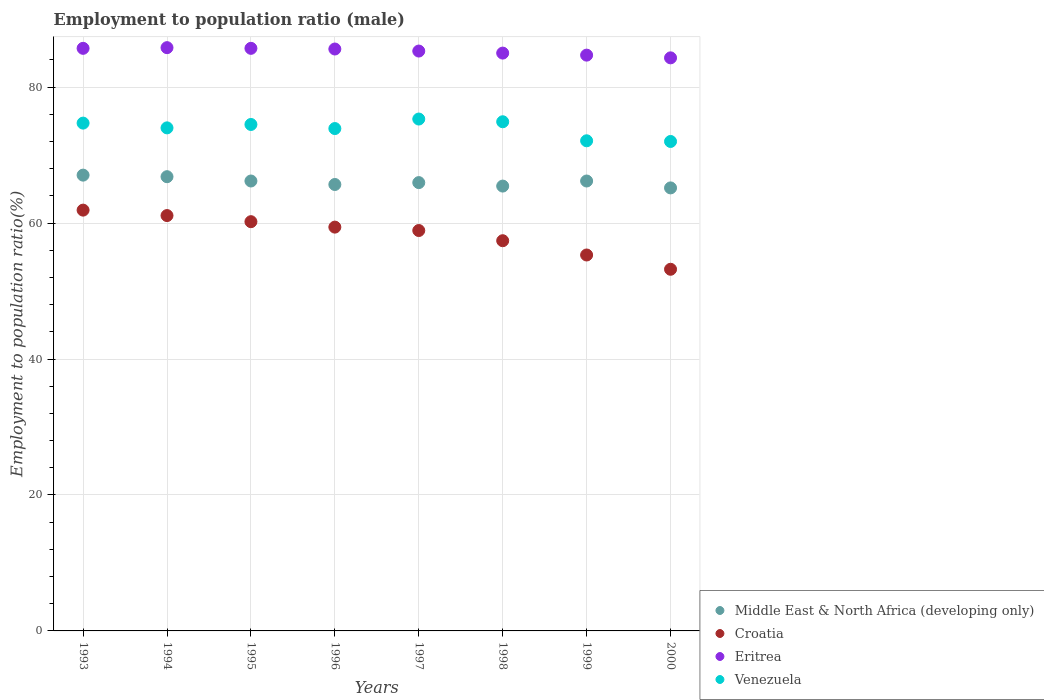What is the employment to population ratio in Croatia in 1996?
Give a very brief answer. 59.4. Across all years, what is the maximum employment to population ratio in Eritrea?
Ensure brevity in your answer.  85.8. What is the total employment to population ratio in Middle East & North Africa (developing only) in the graph?
Your answer should be very brief. 528.46. What is the difference between the employment to population ratio in Venezuela in 1994 and that in 1996?
Offer a terse response. 0.1. What is the average employment to population ratio in Eritrea per year?
Your response must be concise. 85.26. In the year 1998, what is the difference between the employment to population ratio in Croatia and employment to population ratio in Venezuela?
Offer a terse response. -17.5. In how many years, is the employment to population ratio in Venezuela greater than 4 %?
Offer a very short reply. 8. What is the ratio of the employment to population ratio in Croatia in 1996 to that in 2000?
Provide a succinct answer. 1.12. Is the employment to population ratio in Middle East & North Africa (developing only) in 1995 less than that in 1999?
Make the answer very short. No. Is the difference between the employment to population ratio in Croatia in 1995 and 1998 greater than the difference between the employment to population ratio in Venezuela in 1995 and 1998?
Make the answer very short. Yes. What is the difference between the highest and the second highest employment to population ratio in Venezuela?
Your answer should be compact. 0.4. What is the difference between the highest and the lowest employment to population ratio in Middle East & North Africa (developing only)?
Ensure brevity in your answer.  1.88. Is it the case that in every year, the sum of the employment to population ratio in Croatia and employment to population ratio in Venezuela  is greater than the employment to population ratio in Eritrea?
Provide a short and direct response. Yes. Is the employment to population ratio in Middle East & North Africa (developing only) strictly less than the employment to population ratio in Eritrea over the years?
Offer a very short reply. Yes. How many years are there in the graph?
Offer a very short reply. 8. Are the values on the major ticks of Y-axis written in scientific E-notation?
Offer a very short reply. No. Does the graph contain any zero values?
Your response must be concise. No. Does the graph contain grids?
Ensure brevity in your answer.  Yes. How many legend labels are there?
Offer a very short reply. 4. How are the legend labels stacked?
Keep it short and to the point. Vertical. What is the title of the graph?
Ensure brevity in your answer.  Employment to population ratio (male). What is the Employment to population ratio(%) in Middle East & North Africa (developing only) in 1993?
Offer a very short reply. 67.05. What is the Employment to population ratio(%) of Croatia in 1993?
Offer a terse response. 61.9. What is the Employment to population ratio(%) in Eritrea in 1993?
Your response must be concise. 85.7. What is the Employment to population ratio(%) of Venezuela in 1993?
Provide a short and direct response. 74.7. What is the Employment to population ratio(%) of Middle East & North Africa (developing only) in 1994?
Make the answer very short. 66.82. What is the Employment to population ratio(%) in Croatia in 1994?
Your answer should be very brief. 61.1. What is the Employment to population ratio(%) in Eritrea in 1994?
Ensure brevity in your answer.  85.8. What is the Employment to population ratio(%) in Venezuela in 1994?
Offer a terse response. 74. What is the Employment to population ratio(%) of Middle East & North Africa (developing only) in 1995?
Your answer should be very brief. 66.18. What is the Employment to population ratio(%) in Croatia in 1995?
Your answer should be compact. 60.2. What is the Employment to population ratio(%) of Eritrea in 1995?
Offer a terse response. 85.7. What is the Employment to population ratio(%) of Venezuela in 1995?
Offer a very short reply. 74.5. What is the Employment to population ratio(%) of Middle East & North Africa (developing only) in 1996?
Give a very brief answer. 65.67. What is the Employment to population ratio(%) of Croatia in 1996?
Provide a short and direct response. 59.4. What is the Employment to population ratio(%) of Eritrea in 1996?
Make the answer very short. 85.6. What is the Employment to population ratio(%) in Venezuela in 1996?
Provide a succinct answer. 73.9. What is the Employment to population ratio(%) of Middle East & North Africa (developing only) in 1997?
Offer a very short reply. 65.95. What is the Employment to population ratio(%) of Croatia in 1997?
Give a very brief answer. 58.9. What is the Employment to population ratio(%) in Eritrea in 1997?
Give a very brief answer. 85.3. What is the Employment to population ratio(%) in Venezuela in 1997?
Your answer should be very brief. 75.3. What is the Employment to population ratio(%) in Middle East & North Africa (developing only) in 1998?
Make the answer very short. 65.44. What is the Employment to population ratio(%) in Croatia in 1998?
Offer a terse response. 57.4. What is the Employment to population ratio(%) of Eritrea in 1998?
Your response must be concise. 85. What is the Employment to population ratio(%) in Venezuela in 1998?
Offer a terse response. 74.9. What is the Employment to population ratio(%) of Middle East & North Africa (developing only) in 1999?
Your response must be concise. 66.18. What is the Employment to population ratio(%) of Croatia in 1999?
Ensure brevity in your answer.  55.3. What is the Employment to population ratio(%) of Eritrea in 1999?
Your answer should be compact. 84.7. What is the Employment to population ratio(%) of Venezuela in 1999?
Your response must be concise. 72.1. What is the Employment to population ratio(%) of Middle East & North Africa (developing only) in 2000?
Ensure brevity in your answer.  65.17. What is the Employment to population ratio(%) of Croatia in 2000?
Give a very brief answer. 53.2. What is the Employment to population ratio(%) of Eritrea in 2000?
Offer a terse response. 84.3. What is the Employment to population ratio(%) in Venezuela in 2000?
Your answer should be compact. 72. Across all years, what is the maximum Employment to population ratio(%) in Middle East & North Africa (developing only)?
Provide a short and direct response. 67.05. Across all years, what is the maximum Employment to population ratio(%) in Croatia?
Your response must be concise. 61.9. Across all years, what is the maximum Employment to population ratio(%) of Eritrea?
Offer a terse response. 85.8. Across all years, what is the maximum Employment to population ratio(%) of Venezuela?
Offer a very short reply. 75.3. Across all years, what is the minimum Employment to population ratio(%) in Middle East & North Africa (developing only)?
Offer a very short reply. 65.17. Across all years, what is the minimum Employment to population ratio(%) in Croatia?
Make the answer very short. 53.2. Across all years, what is the minimum Employment to population ratio(%) of Eritrea?
Offer a terse response. 84.3. What is the total Employment to population ratio(%) in Middle East & North Africa (developing only) in the graph?
Give a very brief answer. 528.46. What is the total Employment to population ratio(%) of Croatia in the graph?
Keep it short and to the point. 467.4. What is the total Employment to population ratio(%) of Eritrea in the graph?
Keep it short and to the point. 682.1. What is the total Employment to population ratio(%) of Venezuela in the graph?
Keep it short and to the point. 591.4. What is the difference between the Employment to population ratio(%) of Middle East & North Africa (developing only) in 1993 and that in 1994?
Provide a short and direct response. 0.23. What is the difference between the Employment to population ratio(%) of Eritrea in 1993 and that in 1994?
Keep it short and to the point. -0.1. What is the difference between the Employment to population ratio(%) of Venezuela in 1993 and that in 1994?
Your answer should be compact. 0.7. What is the difference between the Employment to population ratio(%) of Middle East & North Africa (developing only) in 1993 and that in 1995?
Your answer should be very brief. 0.86. What is the difference between the Employment to population ratio(%) in Eritrea in 1993 and that in 1995?
Your response must be concise. 0. What is the difference between the Employment to population ratio(%) in Venezuela in 1993 and that in 1995?
Make the answer very short. 0.2. What is the difference between the Employment to population ratio(%) in Middle East & North Africa (developing only) in 1993 and that in 1996?
Your response must be concise. 1.38. What is the difference between the Employment to population ratio(%) of Croatia in 1993 and that in 1996?
Provide a short and direct response. 2.5. What is the difference between the Employment to population ratio(%) in Venezuela in 1993 and that in 1996?
Your response must be concise. 0.8. What is the difference between the Employment to population ratio(%) in Middle East & North Africa (developing only) in 1993 and that in 1997?
Give a very brief answer. 1.1. What is the difference between the Employment to population ratio(%) of Croatia in 1993 and that in 1997?
Provide a short and direct response. 3. What is the difference between the Employment to population ratio(%) in Middle East & North Africa (developing only) in 1993 and that in 1998?
Keep it short and to the point. 1.61. What is the difference between the Employment to population ratio(%) of Croatia in 1993 and that in 1998?
Your answer should be very brief. 4.5. What is the difference between the Employment to population ratio(%) of Eritrea in 1993 and that in 1998?
Your response must be concise. 0.7. What is the difference between the Employment to population ratio(%) of Middle East & North Africa (developing only) in 1993 and that in 1999?
Offer a terse response. 0.86. What is the difference between the Employment to population ratio(%) in Croatia in 1993 and that in 1999?
Offer a terse response. 6.6. What is the difference between the Employment to population ratio(%) of Eritrea in 1993 and that in 1999?
Offer a very short reply. 1. What is the difference between the Employment to population ratio(%) of Venezuela in 1993 and that in 1999?
Ensure brevity in your answer.  2.6. What is the difference between the Employment to population ratio(%) of Middle East & North Africa (developing only) in 1993 and that in 2000?
Your answer should be very brief. 1.88. What is the difference between the Employment to population ratio(%) in Venezuela in 1993 and that in 2000?
Make the answer very short. 2.7. What is the difference between the Employment to population ratio(%) in Middle East & North Africa (developing only) in 1994 and that in 1995?
Offer a terse response. 0.63. What is the difference between the Employment to population ratio(%) of Croatia in 1994 and that in 1995?
Your response must be concise. 0.9. What is the difference between the Employment to population ratio(%) in Middle East & North Africa (developing only) in 1994 and that in 1996?
Your response must be concise. 1.15. What is the difference between the Employment to population ratio(%) of Middle East & North Africa (developing only) in 1994 and that in 1997?
Your response must be concise. 0.87. What is the difference between the Employment to population ratio(%) in Eritrea in 1994 and that in 1997?
Offer a very short reply. 0.5. What is the difference between the Employment to population ratio(%) of Venezuela in 1994 and that in 1997?
Your answer should be compact. -1.3. What is the difference between the Employment to population ratio(%) in Middle East & North Africa (developing only) in 1994 and that in 1998?
Provide a succinct answer. 1.38. What is the difference between the Employment to population ratio(%) in Croatia in 1994 and that in 1998?
Your answer should be compact. 3.7. What is the difference between the Employment to population ratio(%) in Eritrea in 1994 and that in 1998?
Your answer should be very brief. 0.8. What is the difference between the Employment to population ratio(%) in Venezuela in 1994 and that in 1998?
Provide a short and direct response. -0.9. What is the difference between the Employment to population ratio(%) in Middle East & North Africa (developing only) in 1994 and that in 1999?
Provide a succinct answer. 0.63. What is the difference between the Employment to population ratio(%) in Croatia in 1994 and that in 1999?
Offer a terse response. 5.8. What is the difference between the Employment to population ratio(%) of Eritrea in 1994 and that in 1999?
Make the answer very short. 1.1. What is the difference between the Employment to population ratio(%) of Venezuela in 1994 and that in 1999?
Your answer should be compact. 1.9. What is the difference between the Employment to population ratio(%) in Middle East & North Africa (developing only) in 1994 and that in 2000?
Your answer should be very brief. 1.65. What is the difference between the Employment to population ratio(%) of Eritrea in 1994 and that in 2000?
Make the answer very short. 1.5. What is the difference between the Employment to population ratio(%) in Venezuela in 1994 and that in 2000?
Offer a terse response. 2. What is the difference between the Employment to population ratio(%) of Middle East & North Africa (developing only) in 1995 and that in 1996?
Offer a terse response. 0.51. What is the difference between the Employment to population ratio(%) of Croatia in 1995 and that in 1996?
Offer a terse response. 0.8. What is the difference between the Employment to population ratio(%) in Eritrea in 1995 and that in 1996?
Ensure brevity in your answer.  0.1. What is the difference between the Employment to population ratio(%) of Venezuela in 1995 and that in 1996?
Offer a very short reply. 0.6. What is the difference between the Employment to population ratio(%) of Middle East & North Africa (developing only) in 1995 and that in 1997?
Give a very brief answer. 0.24. What is the difference between the Employment to population ratio(%) of Croatia in 1995 and that in 1997?
Your answer should be very brief. 1.3. What is the difference between the Employment to population ratio(%) of Eritrea in 1995 and that in 1997?
Make the answer very short. 0.4. What is the difference between the Employment to population ratio(%) in Venezuela in 1995 and that in 1997?
Your answer should be very brief. -0.8. What is the difference between the Employment to population ratio(%) of Middle East & North Africa (developing only) in 1995 and that in 1998?
Provide a succinct answer. 0.75. What is the difference between the Employment to population ratio(%) in Eritrea in 1995 and that in 1998?
Make the answer very short. 0.7. What is the difference between the Employment to population ratio(%) in Eritrea in 1995 and that in 1999?
Give a very brief answer. 1. What is the difference between the Employment to population ratio(%) in Middle East & North Africa (developing only) in 1995 and that in 2000?
Make the answer very short. 1.02. What is the difference between the Employment to population ratio(%) in Croatia in 1995 and that in 2000?
Your answer should be compact. 7. What is the difference between the Employment to population ratio(%) of Eritrea in 1995 and that in 2000?
Offer a very short reply. 1.4. What is the difference between the Employment to population ratio(%) in Venezuela in 1995 and that in 2000?
Give a very brief answer. 2.5. What is the difference between the Employment to population ratio(%) in Middle East & North Africa (developing only) in 1996 and that in 1997?
Keep it short and to the point. -0.28. What is the difference between the Employment to population ratio(%) in Venezuela in 1996 and that in 1997?
Offer a terse response. -1.4. What is the difference between the Employment to population ratio(%) of Middle East & North Africa (developing only) in 1996 and that in 1998?
Give a very brief answer. 0.23. What is the difference between the Employment to population ratio(%) of Eritrea in 1996 and that in 1998?
Your answer should be very brief. 0.6. What is the difference between the Employment to population ratio(%) of Venezuela in 1996 and that in 1998?
Provide a succinct answer. -1. What is the difference between the Employment to population ratio(%) in Middle East & North Africa (developing only) in 1996 and that in 1999?
Your response must be concise. -0.51. What is the difference between the Employment to population ratio(%) of Middle East & North Africa (developing only) in 1996 and that in 2000?
Offer a very short reply. 0.5. What is the difference between the Employment to population ratio(%) of Croatia in 1996 and that in 2000?
Your answer should be very brief. 6.2. What is the difference between the Employment to population ratio(%) in Venezuela in 1996 and that in 2000?
Make the answer very short. 1.9. What is the difference between the Employment to population ratio(%) of Middle East & North Africa (developing only) in 1997 and that in 1998?
Offer a very short reply. 0.51. What is the difference between the Employment to population ratio(%) of Eritrea in 1997 and that in 1998?
Offer a terse response. 0.3. What is the difference between the Employment to population ratio(%) of Venezuela in 1997 and that in 1998?
Offer a terse response. 0.4. What is the difference between the Employment to population ratio(%) in Middle East & North Africa (developing only) in 1997 and that in 1999?
Keep it short and to the point. -0.24. What is the difference between the Employment to population ratio(%) in Middle East & North Africa (developing only) in 1997 and that in 2000?
Provide a short and direct response. 0.78. What is the difference between the Employment to population ratio(%) in Croatia in 1997 and that in 2000?
Give a very brief answer. 5.7. What is the difference between the Employment to population ratio(%) of Middle East & North Africa (developing only) in 1998 and that in 1999?
Your response must be concise. -0.75. What is the difference between the Employment to population ratio(%) of Croatia in 1998 and that in 1999?
Offer a terse response. 2.1. What is the difference between the Employment to population ratio(%) in Middle East & North Africa (developing only) in 1998 and that in 2000?
Keep it short and to the point. 0.27. What is the difference between the Employment to population ratio(%) of Venezuela in 1998 and that in 2000?
Offer a very short reply. 2.9. What is the difference between the Employment to population ratio(%) of Middle East & North Africa (developing only) in 1999 and that in 2000?
Give a very brief answer. 1.02. What is the difference between the Employment to population ratio(%) in Middle East & North Africa (developing only) in 1993 and the Employment to population ratio(%) in Croatia in 1994?
Ensure brevity in your answer.  5.95. What is the difference between the Employment to population ratio(%) in Middle East & North Africa (developing only) in 1993 and the Employment to population ratio(%) in Eritrea in 1994?
Your answer should be very brief. -18.75. What is the difference between the Employment to population ratio(%) in Middle East & North Africa (developing only) in 1993 and the Employment to population ratio(%) in Venezuela in 1994?
Your response must be concise. -6.95. What is the difference between the Employment to population ratio(%) in Croatia in 1993 and the Employment to population ratio(%) in Eritrea in 1994?
Offer a very short reply. -23.9. What is the difference between the Employment to population ratio(%) of Croatia in 1993 and the Employment to population ratio(%) of Venezuela in 1994?
Provide a short and direct response. -12.1. What is the difference between the Employment to population ratio(%) of Middle East & North Africa (developing only) in 1993 and the Employment to population ratio(%) of Croatia in 1995?
Your answer should be compact. 6.85. What is the difference between the Employment to population ratio(%) in Middle East & North Africa (developing only) in 1993 and the Employment to population ratio(%) in Eritrea in 1995?
Give a very brief answer. -18.65. What is the difference between the Employment to population ratio(%) of Middle East & North Africa (developing only) in 1993 and the Employment to population ratio(%) of Venezuela in 1995?
Offer a terse response. -7.45. What is the difference between the Employment to population ratio(%) of Croatia in 1993 and the Employment to population ratio(%) of Eritrea in 1995?
Your answer should be compact. -23.8. What is the difference between the Employment to population ratio(%) of Eritrea in 1993 and the Employment to population ratio(%) of Venezuela in 1995?
Provide a succinct answer. 11.2. What is the difference between the Employment to population ratio(%) of Middle East & North Africa (developing only) in 1993 and the Employment to population ratio(%) of Croatia in 1996?
Your answer should be compact. 7.65. What is the difference between the Employment to population ratio(%) of Middle East & North Africa (developing only) in 1993 and the Employment to population ratio(%) of Eritrea in 1996?
Your answer should be very brief. -18.55. What is the difference between the Employment to population ratio(%) in Middle East & North Africa (developing only) in 1993 and the Employment to population ratio(%) in Venezuela in 1996?
Your answer should be compact. -6.85. What is the difference between the Employment to population ratio(%) in Croatia in 1993 and the Employment to population ratio(%) in Eritrea in 1996?
Provide a short and direct response. -23.7. What is the difference between the Employment to population ratio(%) in Middle East & North Africa (developing only) in 1993 and the Employment to population ratio(%) in Croatia in 1997?
Offer a very short reply. 8.15. What is the difference between the Employment to population ratio(%) of Middle East & North Africa (developing only) in 1993 and the Employment to population ratio(%) of Eritrea in 1997?
Your answer should be very brief. -18.25. What is the difference between the Employment to population ratio(%) of Middle East & North Africa (developing only) in 1993 and the Employment to population ratio(%) of Venezuela in 1997?
Your response must be concise. -8.25. What is the difference between the Employment to population ratio(%) in Croatia in 1993 and the Employment to population ratio(%) in Eritrea in 1997?
Your answer should be very brief. -23.4. What is the difference between the Employment to population ratio(%) of Eritrea in 1993 and the Employment to population ratio(%) of Venezuela in 1997?
Your answer should be compact. 10.4. What is the difference between the Employment to population ratio(%) of Middle East & North Africa (developing only) in 1993 and the Employment to population ratio(%) of Croatia in 1998?
Your answer should be compact. 9.65. What is the difference between the Employment to population ratio(%) of Middle East & North Africa (developing only) in 1993 and the Employment to population ratio(%) of Eritrea in 1998?
Your response must be concise. -17.95. What is the difference between the Employment to population ratio(%) of Middle East & North Africa (developing only) in 1993 and the Employment to population ratio(%) of Venezuela in 1998?
Keep it short and to the point. -7.85. What is the difference between the Employment to population ratio(%) of Croatia in 1993 and the Employment to population ratio(%) of Eritrea in 1998?
Make the answer very short. -23.1. What is the difference between the Employment to population ratio(%) of Middle East & North Africa (developing only) in 1993 and the Employment to population ratio(%) of Croatia in 1999?
Offer a very short reply. 11.75. What is the difference between the Employment to population ratio(%) in Middle East & North Africa (developing only) in 1993 and the Employment to population ratio(%) in Eritrea in 1999?
Your response must be concise. -17.65. What is the difference between the Employment to population ratio(%) of Middle East & North Africa (developing only) in 1993 and the Employment to population ratio(%) of Venezuela in 1999?
Provide a succinct answer. -5.05. What is the difference between the Employment to population ratio(%) of Croatia in 1993 and the Employment to population ratio(%) of Eritrea in 1999?
Ensure brevity in your answer.  -22.8. What is the difference between the Employment to population ratio(%) in Croatia in 1993 and the Employment to population ratio(%) in Venezuela in 1999?
Provide a short and direct response. -10.2. What is the difference between the Employment to population ratio(%) in Middle East & North Africa (developing only) in 1993 and the Employment to population ratio(%) in Croatia in 2000?
Offer a very short reply. 13.85. What is the difference between the Employment to population ratio(%) in Middle East & North Africa (developing only) in 1993 and the Employment to population ratio(%) in Eritrea in 2000?
Make the answer very short. -17.25. What is the difference between the Employment to population ratio(%) in Middle East & North Africa (developing only) in 1993 and the Employment to population ratio(%) in Venezuela in 2000?
Make the answer very short. -4.95. What is the difference between the Employment to population ratio(%) in Croatia in 1993 and the Employment to population ratio(%) in Eritrea in 2000?
Offer a terse response. -22.4. What is the difference between the Employment to population ratio(%) of Eritrea in 1993 and the Employment to population ratio(%) of Venezuela in 2000?
Ensure brevity in your answer.  13.7. What is the difference between the Employment to population ratio(%) of Middle East & North Africa (developing only) in 1994 and the Employment to population ratio(%) of Croatia in 1995?
Make the answer very short. 6.62. What is the difference between the Employment to population ratio(%) of Middle East & North Africa (developing only) in 1994 and the Employment to population ratio(%) of Eritrea in 1995?
Your response must be concise. -18.88. What is the difference between the Employment to population ratio(%) in Middle East & North Africa (developing only) in 1994 and the Employment to population ratio(%) in Venezuela in 1995?
Your answer should be compact. -7.68. What is the difference between the Employment to population ratio(%) in Croatia in 1994 and the Employment to population ratio(%) in Eritrea in 1995?
Provide a short and direct response. -24.6. What is the difference between the Employment to population ratio(%) in Croatia in 1994 and the Employment to population ratio(%) in Venezuela in 1995?
Ensure brevity in your answer.  -13.4. What is the difference between the Employment to population ratio(%) in Middle East & North Africa (developing only) in 1994 and the Employment to population ratio(%) in Croatia in 1996?
Your response must be concise. 7.42. What is the difference between the Employment to population ratio(%) in Middle East & North Africa (developing only) in 1994 and the Employment to population ratio(%) in Eritrea in 1996?
Your response must be concise. -18.78. What is the difference between the Employment to population ratio(%) in Middle East & North Africa (developing only) in 1994 and the Employment to population ratio(%) in Venezuela in 1996?
Provide a short and direct response. -7.08. What is the difference between the Employment to population ratio(%) in Croatia in 1994 and the Employment to population ratio(%) in Eritrea in 1996?
Provide a short and direct response. -24.5. What is the difference between the Employment to population ratio(%) in Croatia in 1994 and the Employment to population ratio(%) in Venezuela in 1996?
Your answer should be compact. -12.8. What is the difference between the Employment to population ratio(%) of Middle East & North Africa (developing only) in 1994 and the Employment to population ratio(%) of Croatia in 1997?
Keep it short and to the point. 7.92. What is the difference between the Employment to population ratio(%) in Middle East & North Africa (developing only) in 1994 and the Employment to population ratio(%) in Eritrea in 1997?
Make the answer very short. -18.48. What is the difference between the Employment to population ratio(%) of Middle East & North Africa (developing only) in 1994 and the Employment to population ratio(%) of Venezuela in 1997?
Provide a succinct answer. -8.48. What is the difference between the Employment to population ratio(%) of Croatia in 1994 and the Employment to population ratio(%) of Eritrea in 1997?
Provide a succinct answer. -24.2. What is the difference between the Employment to population ratio(%) in Croatia in 1994 and the Employment to population ratio(%) in Venezuela in 1997?
Give a very brief answer. -14.2. What is the difference between the Employment to population ratio(%) of Eritrea in 1994 and the Employment to population ratio(%) of Venezuela in 1997?
Your response must be concise. 10.5. What is the difference between the Employment to population ratio(%) of Middle East & North Africa (developing only) in 1994 and the Employment to population ratio(%) of Croatia in 1998?
Your answer should be very brief. 9.42. What is the difference between the Employment to population ratio(%) of Middle East & North Africa (developing only) in 1994 and the Employment to population ratio(%) of Eritrea in 1998?
Your response must be concise. -18.18. What is the difference between the Employment to population ratio(%) of Middle East & North Africa (developing only) in 1994 and the Employment to population ratio(%) of Venezuela in 1998?
Make the answer very short. -8.08. What is the difference between the Employment to population ratio(%) in Croatia in 1994 and the Employment to population ratio(%) in Eritrea in 1998?
Your answer should be very brief. -23.9. What is the difference between the Employment to population ratio(%) of Middle East & North Africa (developing only) in 1994 and the Employment to population ratio(%) of Croatia in 1999?
Provide a succinct answer. 11.52. What is the difference between the Employment to population ratio(%) of Middle East & North Africa (developing only) in 1994 and the Employment to population ratio(%) of Eritrea in 1999?
Keep it short and to the point. -17.88. What is the difference between the Employment to population ratio(%) in Middle East & North Africa (developing only) in 1994 and the Employment to population ratio(%) in Venezuela in 1999?
Make the answer very short. -5.28. What is the difference between the Employment to population ratio(%) in Croatia in 1994 and the Employment to population ratio(%) in Eritrea in 1999?
Offer a terse response. -23.6. What is the difference between the Employment to population ratio(%) in Middle East & North Africa (developing only) in 1994 and the Employment to population ratio(%) in Croatia in 2000?
Offer a very short reply. 13.62. What is the difference between the Employment to population ratio(%) in Middle East & North Africa (developing only) in 1994 and the Employment to population ratio(%) in Eritrea in 2000?
Your answer should be very brief. -17.48. What is the difference between the Employment to population ratio(%) of Middle East & North Africa (developing only) in 1994 and the Employment to population ratio(%) of Venezuela in 2000?
Offer a very short reply. -5.18. What is the difference between the Employment to population ratio(%) of Croatia in 1994 and the Employment to population ratio(%) of Eritrea in 2000?
Keep it short and to the point. -23.2. What is the difference between the Employment to population ratio(%) in Croatia in 1994 and the Employment to population ratio(%) in Venezuela in 2000?
Your answer should be very brief. -10.9. What is the difference between the Employment to population ratio(%) in Eritrea in 1994 and the Employment to population ratio(%) in Venezuela in 2000?
Your answer should be compact. 13.8. What is the difference between the Employment to population ratio(%) of Middle East & North Africa (developing only) in 1995 and the Employment to population ratio(%) of Croatia in 1996?
Make the answer very short. 6.78. What is the difference between the Employment to population ratio(%) in Middle East & North Africa (developing only) in 1995 and the Employment to population ratio(%) in Eritrea in 1996?
Provide a short and direct response. -19.42. What is the difference between the Employment to population ratio(%) in Middle East & North Africa (developing only) in 1995 and the Employment to population ratio(%) in Venezuela in 1996?
Your answer should be compact. -7.72. What is the difference between the Employment to population ratio(%) of Croatia in 1995 and the Employment to population ratio(%) of Eritrea in 1996?
Give a very brief answer. -25.4. What is the difference between the Employment to population ratio(%) of Croatia in 1995 and the Employment to population ratio(%) of Venezuela in 1996?
Make the answer very short. -13.7. What is the difference between the Employment to population ratio(%) in Eritrea in 1995 and the Employment to population ratio(%) in Venezuela in 1996?
Ensure brevity in your answer.  11.8. What is the difference between the Employment to population ratio(%) of Middle East & North Africa (developing only) in 1995 and the Employment to population ratio(%) of Croatia in 1997?
Provide a short and direct response. 7.28. What is the difference between the Employment to population ratio(%) of Middle East & North Africa (developing only) in 1995 and the Employment to population ratio(%) of Eritrea in 1997?
Provide a succinct answer. -19.12. What is the difference between the Employment to population ratio(%) in Middle East & North Africa (developing only) in 1995 and the Employment to population ratio(%) in Venezuela in 1997?
Offer a terse response. -9.12. What is the difference between the Employment to population ratio(%) in Croatia in 1995 and the Employment to population ratio(%) in Eritrea in 1997?
Your answer should be compact. -25.1. What is the difference between the Employment to population ratio(%) in Croatia in 1995 and the Employment to population ratio(%) in Venezuela in 1997?
Make the answer very short. -15.1. What is the difference between the Employment to population ratio(%) of Eritrea in 1995 and the Employment to population ratio(%) of Venezuela in 1997?
Your response must be concise. 10.4. What is the difference between the Employment to population ratio(%) in Middle East & North Africa (developing only) in 1995 and the Employment to population ratio(%) in Croatia in 1998?
Ensure brevity in your answer.  8.78. What is the difference between the Employment to population ratio(%) of Middle East & North Africa (developing only) in 1995 and the Employment to population ratio(%) of Eritrea in 1998?
Give a very brief answer. -18.82. What is the difference between the Employment to population ratio(%) in Middle East & North Africa (developing only) in 1995 and the Employment to population ratio(%) in Venezuela in 1998?
Give a very brief answer. -8.72. What is the difference between the Employment to population ratio(%) in Croatia in 1995 and the Employment to population ratio(%) in Eritrea in 1998?
Offer a terse response. -24.8. What is the difference between the Employment to population ratio(%) in Croatia in 1995 and the Employment to population ratio(%) in Venezuela in 1998?
Provide a succinct answer. -14.7. What is the difference between the Employment to population ratio(%) in Middle East & North Africa (developing only) in 1995 and the Employment to population ratio(%) in Croatia in 1999?
Provide a succinct answer. 10.88. What is the difference between the Employment to population ratio(%) of Middle East & North Africa (developing only) in 1995 and the Employment to population ratio(%) of Eritrea in 1999?
Offer a terse response. -18.52. What is the difference between the Employment to population ratio(%) in Middle East & North Africa (developing only) in 1995 and the Employment to population ratio(%) in Venezuela in 1999?
Your answer should be very brief. -5.92. What is the difference between the Employment to population ratio(%) in Croatia in 1995 and the Employment to population ratio(%) in Eritrea in 1999?
Keep it short and to the point. -24.5. What is the difference between the Employment to population ratio(%) in Eritrea in 1995 and the Employment to population ratio(%) in Venezuela in 1999?
Your answer should be very brief. 13.6. What is the difference between the Employment to population ratio(%) of Middle East & North Africa (developing only) in 1995 and the Employment to population ratio(%) of Croatia in 2000?
Ensure brevity in your answer.  12.98. What is the difference between the Employment to population ratio(%) in Middle East & North Africa (developing only) in 1995 and the Employment to population ratio(%) in Eritrea in 2000?
Your response must be concise. -18.12. What is the difference between the Employment to population ratio(%) of Middle East & North Africa (developing only) in 1995 and the Employment to population ratio(%) of Venezuela in 2000?
Your response must be concise. -5.82. What is the difference between the Employment to population ratio(%) in Croatia in 1995 and the Employment to population ratio(%) in Eritrea in 2000?
Your response must be concise. -24.1. What is the difference between the Employment to population ratio(%) of Eritrea in 1995 and the Employment to population ratio(%) of Venezuela in 2000?
Provide a succinct answer. 13.7. What is the difference between the Employment to population ratio(%) in Middle East & North Africa (developing only) in 1996 and the Employment to population ratio(%) in Croatia in 1997?
Keep it short and to the point. 6.77. What is the difference between the Employment to population ratio(%) of Middle East & North Africa (developing only) in 1996 and the Employment to population ratio(%) of Eritrea in 1997?
Your response must be concise. -19.63. What is the difference between the Employment to population ratio(%) in Middle East & North Africa (developing only) in 1996 and the Employment to population ratio(%) in Venezuela in 1997?
Offer a very short reply. -9.63. What is the difference between the Employment to population ratio(%) in Croatia in 1996 and the Employment to population ratio(%) in Eritrea in 1997?
Offer a very short reply. -25.9. What is the difference between the Employment to population ratio(%) of Croatia in 1996 and the Employment to population ratio(%) of Venezuela in 1997?
Your response must be concise. -15.9. What is the difference between the Employment to population ratio(%) of Eritrea in 1996 and the Employment to population ratio(%) of Venezuela in 1997?
Offer a very short reply. 10.3. What is the difference between the Employment to population ratio(%) of Middle East & North Africa (developing only) in 1996 and the Employment to population ratio(%) of Croatia in 1998?
Offer a very short reply. 8.27. What is the difference between the Employment to population ratio(%) of Middle East & North Africa (developing only) in 1996 and the Employment to population ratio(%) of Eritrea in 1998?
Your answer should be compact. -19.33. What is the difference between the Employment to population ratio(%) of Middle East & North Africa (developing only) in 1996 and the Employment to population ratio(%) of Venezuela in 1998?
Give a very brief answer. -9.23. What is the difference between the Employment to population ratio(%) of Croatia in 1996 and the Employment to population ratio(%) of Eritrea in 1998?
Keep it short and to the point. -25.6. What is the difference between the Employment to population ratio(%) in Croatia in 1996 and the Employment to population ratio(%) in Venezuela in 1998?
Your answer should be compact. -15.5. What is the difference between the Employment to population ratio(%) of Middle East & North Africa (developing only) in 1996 and the Employment to population ratio(%) of Croatia in 1999?
Provide a short and direct response. 10.37. What is the difference between the Employment to population ratio(%) of Middle East & North Africa (developing only) in 1996 and the Employment to population ratio(%) of Eritrea in 1999?
Give a very brief answer. -19.03. What is the difference between the Employment to population ratio(%) of Middle East & North Africa (developing only) in 1996 and the Employment to population ratio(%) of Venezuela in 1999?
Make the answer very short. -6.43. What is the difference between the Employment to population ratio(%) in Croatia in 1996 and the Employment to population ratio(%) in Eritrea in 1999?
Provide a succinct answer. -25.3. What is the difference between the Employment to population ratio(%) in Eritrea in 1996 and the Employment to population ratio(%) in Venezuela in 1999?
Provide a short and direct response. 13.5. What is the difference between the Employment to population ratio(%) in Middle East & North Africa (developing only) in 1996 and the Employment to population ratio(%) in Croatia in 2000?
Offer a terse response. 12.47. What is the difference between the Employment to population ratio(%) in Middle East & North Africa (developing only) in 1996 and the Employment to population ratio(%) in Eritrea in 2000?
Your answer should be very brief. -18.63. What is the difference between the Employment to population ratio(%) in Middle East & North Africa (developing only) in 1996 and the Employment to population ratio(%) in Venezuela in 2000?
Offer a terse response. -6.33. What is the difference between the Employment to population ratio(%) of Croatia in 1996 and the Employment to population ratio(%) of Eritrea in 2000?
Make the answer very short. -24.9. What is the difference between the Employment to population ratio(%) of Eritrea in 1996 and the Employment to population ratio(%) of Venezuela in 2000?
Your response must be concise. 13.6. What is the difference between the Employment to population ratio(%) of Middle East & North Africa (developing only) in 1997 and the Employment to population ratio(%) of Croatia in 1998?
Offer a very short reply. 8.55. What is the difference between the Employment to population ratio(%) of Middle East & North Africa (developing only) in 1997 and the Employment to population ratio(%) of Eritrea in 1998?
Your answer should be compact. -19.05. What is the difference between the Employment to population ratio(%) in Middle East & North Africa (developing only) in 1997 and the Employment to population ratio(%) in Venezuela in 1998?
Offer a terse response. -8.95. What is the difference between the Employment to population ratio(%) in Croatia in 1997 and the Employment to population ratio(%) in Eritrea in 1998?
Your answer should be compact. -26.1. What is the difference between the Employment to population ratio(%) of Eritrea in 1997 and the Employment to population ratio(%) of Venezuela in 1998?
Provide a succinct answer. 10.4. What is the difference between the Employment to population ratio(%) of Middle East & North Africa (developing only) in 1997 and the Employment to population ratio(%) of Croatia in 1999?
Your answer should be very brief. 10.65. What is the difference between the Employment to population ratio(%) in Middle East & North Africa (developing only) in 1997 and the Employment to population ratio(%) in Eritrea in 1999?
Keep it short and to the point. -18.75. What is the difference between the Employment to population ratio(%) in Middle East & North Africa (developing only) in 1997 and the Employment to population ratio(%) in Venezuela in 1999?
Your answer should be compact. -6.15. What is the difference between the Employment to population ratio(%) in Croatia in 1997 and the Employment to population ratio(%) in Eritrea in 1999?
Make the answer very short. -25.8. What is the difference between the Employment to population ratio(%) in Eritrea in 1997 and the Employment to population ratio(%) in Venezuela in 1999?
Provide a short and direct response. 13.2. What is the difference between the Employment to population ratio(%) in Middle East & North Africa (developing only) in 1997 and the Employment to population ratio(%) in Croatia in 2000?
Provide a short and direct response. 12.75. What is the difference between the Employment to population ratio(%) of Middle East & North Africa (developing only) in 1997 and the Employment to population ratio(%) of Eritrea in 2000?
Your answer should be compact. -18.35. What is the difference between the Employment to population ratio(%) in Middle East & North Africa (developing only) in 1997 and the Employment to population ratio(%) in Venezuela in 2000?
Give a very brief answer. -6.05. What is the difference between the Employment to population ratio(%) in Croatia in 1997 and the Employment to population ratio(%) in Eritrea in 2000?
Provide a succinct answer. -25.4. What is the difference between the Employment to population ratio(%) of Croatia in 1997 and the Employment to population ratio(%) of Venezuela in 2000?
Ensure brevity in your answer.  -13.1. What is the difference between the Employment to population ratio(%) of Middle East & North Africa (developing only) in 1998 and the Employment to population ratio(%) of Croatia in 1999?
Give a very brief answer. 10.14. What is the difference between the Employment to population ratio(%) of Middle East & North Africa (developing only) in 1998 and the Employment to population ratio(%) of Eritrea in 1999?
Offer a very short reply. -19.26. What is the difference between the Employment to population ratio(%) in Middle East & North Africa (developing only) in 1998 and the Employment to population ratio(%) in Venezuela in 1999?
Make the answer very short. -6.66. What is the difference between the Employment to population ratio(%) in Croatia in 1998 and the Employment to population ratio(%) in Eritrea in 1999?
Ensure brevity in your answer.  -27.3. What is the difference between the Employment to population ratio(%) of Croatia in 1998 and the Employment to population ratio(%) of Venezuela in 1999?
Your response must be concise. -14.7. What is the difference between the Employment to population ratio(%) in Eritrea in 1998 and the Employment to population ratio(%) in Venezuela in 1999?
Your response must be concise. 12.9. What is the difference between the Employment to population ratio(%) of Middle East & North Africa (developing only) in 1998 and the Employment to population ratio(%) of Croatia in 2000?
Make the answer very short. 12.24. What is the difference between the Employment to population ratio(%) of Middle East & North Africa (developing only) in 1998 and the Employment to population ratio(%) of Eritrea in 2000?
Give a very brief answer. -18.86. What is the difference between the Employment to population ratio(%) in Middle East & North Africa (developing only) in 1998 and the Employment to population ratio(%) in Venezuela in 2000?
Offer a terse response. -6.56. What is the difference between the Employment to population ratio(%) of Croatia in 1998 and the Employment to population ratio(%) of Eritrea in 2000?
Ensure brevity in your answer.  -26.9. What is the difference between the Employment to population ratio(%) of Croatia in 1998 and the Employment to population ratio(%) of Venezuela in 2000?
Offer a terse response. -14.6. What is the difference between the Employment to population ratio(%) in Middle East & North Africa (developing only) in 1999 and the Employment to population ratio(%) in Croatia in 2000?
Your response must be concise. 12.98. What is the difference between the Employment to population ratio(%) of Middle East & North Africa (developing only) in 1999 and the Employment to population ratio(%) of Eritrea in 2000?
Provide a succinct answer. -18.12. What is the difference between the Employment to population ratio(%) in Middle East & North Africa (developing only) in 1999 and the Employment to population ratio(%) in Venezuela in 2000?
Provide a succinct answer. -5.82. What is the difference between the Employment to population ratio(%) of Croatia in 1999 and the Employment to population ratio(%) of Eritrea in 2000?
Your answer should be compact. -29. What is the difference between the Employment to population ratio(%) in Croatia in 1999 and the Employment to population ratio(%) in Venezuela in 2000?
Give a very brief answer. -16.7. What is the average Employment to population ratio(%) in Middle East & North Africa (developing only) per year?
Your response must be concise. 66.06. What is the average Employment to population ratio(%) in Croatia per year?
Give a very brief answer. 58.42. What is the average Employment to population ratio(%) of Eritrea per year?
Make the answer very short. 85.26. What is the average Employment to population ratio(%) of Venezuela per year?
Your answer should be compact. 73.92. In the year 1993, what is the difference between the Employment to population ratio(%) of Middle East & North Africa (developing only) and Employment to population ratio(%) of Croatia?
Your answer should be compact. 5.15. In the year 1993, what is the difference between the Employment to population ratio(%) of Middle East & North Africa (developing only) and Employment to population ratio(%) of Eritrea?
Your answer should be very brief. -18.65. In the year 1993, what is the difference between the Employment to population ratio(%) of Middle East & North Africa (developing only) and Employment to population ratio(%) of Venezuela?
Keep it short and to the point. -7.65. In the year 1993, what is the difference between the Employment to population ratio(%) of Croatia and Employment to population ratio(%) of Eritrea?
Offer a terse response. -23.8. In the year 1993, what is the difference between the Employment to population ratio(%) in Eritrea and Employment to population ratio(%) in Venezuela?
Make the answer very short. 11. In the year 1994, what is the difference between the Employment to population ratio(%) in Middle East & North Africa (developing only) and Employment to population ratio(%) in Croatia?
Your answer should be very brief. 5.72. In the year 1994, what is the difference between the Employment to population ratio(%) of Middle East & North Africa (developing only) and Employment to population ratio(%) of Eritrea?
Keep it short and to the point. -18.98. In the year 1994, what is the difference between the Employment to population ratio(%) of Middle East & North Africa (developing only) and Employment to population ratio(%) of Venezuela?
Provide a short and direct response. -7.18. In the year 1994, what is the difference between the Employment to population ratio(%) of Croatia and Employment to population ratio(%) of Eritrea?
Your response must be concise. -24.7. In the year 1994, what is the difference between the Employment to population ratio(%) of Croatia and Employment to population ratio(%) of Venezuela?
Ensure brevity in your answer.  -12.9. In the year 1995, what is the difference between the Employment to population ratio(%) in Middle East & North Africa (developing only) and Employment to population ratio(%) in Croatia?
Offer a very short reply. 5.98. In the year 1995, what is the difference between the Employment to population ratio(%) of Middle East & North Africa (developing only) and Employment to population ratio(%) of Eritrea?
Offer a very short reply. -19.52. In the year 1995, what is the difference between the Employment to population ratio(%) in Middle East & North Africa (developing only) and Employment to population ratio(%) in Venezuela?
Keep it short and to the point. -8.32. In the year 1995, what is the difference between the Employment to population ratio(%) of Croatia and Employment to population ratio(%) of Eritrea?
Provide a short and direct response. -25.5. In the year 1995, what is the difference between the Employment to population ratio(%) of Croatia and Employment to population ratio(%) of Venezuela?
Your answer should be very brief. -14.3. In the year 1996, what is the difference between the Employment to population ratio(%) of Middle East & North Africa (developing only) and Employment to population ratio(%) of Croatia?
Offer a very short reply. 6.27. In the year 1996, what is the difference between the Employment to population ratio(%) of Middle East & North Africa (developing only) and Employment to population ratio(%) of Eritrea?
Provide a short and direct response. -19.93. In the year 1996, what is the difference between the Employment to population ratio(%) in Middle East & North Africa (developing only) and Employment to population ratio(%) in Venezuela?
Give a very brief answer. -8.23. In the year 1996, what is the difference between the Employment to population ratio(%) in Croatia and Employment to population ratio(%) in Eritrea?
Offer a very short reply. -26.2. In the year 1997, what is the difference between the Employment to population ratio(%) of Middle East & North Africa (developing only) and Employment to population ratio(%) of Croatia?
Provide a short and direct response. 7.05. In the year 1997, what is the difference between the Employment to population ratio(%) of Middle East & North Africa (developing only) and Employment to population ratio(%) of Eritrea?
Provide a short and direct response. -19.35. In the year 1997, what is the difference between the Employment to population ratio(%) in Middle East & North Africa (developing only) and Employment to population ratio(%) in Venezuela?
Ensure brevity in your answer.  -9.35. In the year 1997, what is the difference between the Employment to population ratio(%) of Croatia and Employment to population ratio(%) of Eritrea?
Your answer should be compact. -26.4. In the year 1997, what is the difference between the Employment to population ratio(%) in Croatia and Employment to population ratio(%) in Venezuela?
Give a very brief answer. -16.4. In the year 1997, what is the difference between the Employment to population ratio(%) in Eritrea and Employment to population ratio(%) in Venezuela?
Provide a short and direct response. 10. In the year 1998, what is the difference between the Employment to population ratio(%) of Middle East & North Africa (developing only) and Employment to population ratio(%) of Croatia?
Make the answer very short. 8.04. In the year 1998, what is the difference between the Employment to population ratio(%) of Middle East & North Africa (developing only) and Employment to population ratio(%) of Eritrea?
Ensure brevity in your answer.  -19.56. In the year 1998, what is the difference between the Employment to population ratio(%) in Middle East & North Africa (developing only) and Employment to population ratio(%) in Venezuela?
Offer a very short reply. -9.46. In the year 1998, what is the difference between the Employment to population ratio(%) in Croatia and Employment to population ratio(%) in Eritrea?
Provide a succinct answer. -27.6. In the year 1998, what is the difference between the Employment to population ratio(%) in Croatia and Employment to population ratio(%) in Venezuela?
Give a very brief answer. -17.5. In the year 1998, what is the difference between the Employment to population ratio(%) in Eritrea and Employment to population ratio(%) in Venezuela?
Offer a very short reply. 10.1. In the year 1999, what is the difference between the Employment to population ratio(%) in Middle East & North Africa (developing only) and Employment to population ratio(%) in Croatia?
Give a very brief answer. 10.88. In the year 1999, what is the difference between the Employment to population ratio(%) of Middle East & North Africa (developing only) and Employment to population ratio(%) of Eritrea?
Your answer should be very brief. -18.52. In the year 1999, what is the difference between the Employment to population ratio(%) of Middle East & North Africa (developing only) and Employment to population ratio(%) of Venezuela?
Offer a terse response. -5.92. In the year 1999, what is the difference between the Employment to population ratio(%) in Croatia and Employment to population ratio(%) in Eritrea?
Your answer should be compact. -29.4. In the year 1999, what is the difference between the Employment to population ratio(%) in Croatia and Employment to population ratio(%) in Venezuela?
Provide a succinct answer. -16.8. In the year 1999, what is the difference between the Employment to population ratio(%) in Eritrea and Employment to population ratio(%) in Venezuela?
Your response must be concise. 12.6. In the year 2000, what is the difference between the Employment to population ratio(%) of Middle East & North Africa (developing only) and Employment to population ratio(%) of Croatia?
Make the answer very short. 11.97. In the year 2000, what is the difference between the Employment to population ratio(%) in Middle East & North Africa (developing only) and Employment to population ratio(%) in Eritrea?
Your answer should be very brief. -19.13. In the year 2000, what is the difference between the Employment to population ratio(%) in Middle East & North Africa (developing only) and Employment to population ratio(%) in Venezuela?
Your response must be concise. -6.83. In the year 2000, what is the difference between the Employment to population ratio(%) in Croatia and Employment to population ratio(%) in Eritrea?
Make the answer very short. -31.1. In the year 2000, what is the difference between the Employment to population ratio(%) of Croatia and Employment to population ratio(%) of Venezuela?
Your answer should be compact. -18.8. In the year 2000, what is the difference between the Employment to population ratio(%) in Eritrea and Employment to population ratio(%) in Venezuela?
Keep it short and to the point. 12.3. What is the ratio of the Employment to population ratio(%) of Croatia in 1993 to that in 1994?
Offer a terse response. 1.01. What is the ratio of the Employment to population ratio(%) of Eritrea in 1993 to that in 1994?
Your answer should be compact. 1. What is the ratio of the Employment to population ratio(%) in Venezuela in 1993 to that in 1994?
Keep it short and to the point. 1.01. What is the ratio of the Employment to population ratio(%) of Middle East & North Africa (developing only) in 1993 to that in 1995?
Keep it short and to the point. 1.01. What is the ratio of the Employment to population ratio(%) of Croatia in 1993 to that in 1995?
Provide a short and direct response. 1.03. What is the ratio of the Employment to population ratio(%) in Eritrea in 1993 to that in 1995?
Offer a terse response. 1. What is the ratio of the Employment to population ratio(%) of Venezuela in 1993 to that in 1995?
Provide a succinct answer. 1. What is the ratio of the Employment to population ratio(%) of Croatia in 1993 to that in 1996?
Provide a succinct answer. 1.04. What is the ratio of the Employment to population ratio(%) in Venezuela in 1993 to that in 1996?
Provide a succinct answer. 1.01. What is the ratio of the Employment to population ratio(%) of Middle East & North Africa (developing only) in 1993 to that in 1997?
Make the answer very short. 1.02. What is the ratio of the Employment to population ratio(%) of Croatia in 1993 to that in 1997?
Provide a succinct answer. 1.05. What is the ratio of the Employment to population ratio(%) of Middle East & North Africa (developing only) in 1993 to that in 1998?
Keep it short and to the point. 1.02. What is the ratio of the Employment to population ratio(%) in Croatia in 1993 to that in 1998?
Your response must be concise. 1.08. What is the ratio of the Employment to population ratio(%) of Eritrea in 1993 to that in 1998?
Keep it short and to the point. 1.01. What is the ratio of the Employment to population ratio(%) in Croatia in 1993 to that in 1999?
Offer a very short reply. 1.12. What is the ratio of the Employment to population ratio(%) in Eritrea in 1993 to that in 1999?
Your answer should be compact. 1.01. What is the ratio of the Employment to population ratio(%) of Venezuela in 1993 to that in 1999?
Keep it short and to the point. 1.04. What is the ratio of the Employment to population ratio(%) in Middle East & North Africa (developing only) in 1993 to that in 2000?
Ensure brevity in your answer.  1.03. What is the ratio of the Employment to population ratio(%) in Croatia in 1993 to that in 2000?
Ensure brevity in your answer.  1.16. What is the ratio of the Employment to population ratio(%) in Eritrea in 1993 to that in 2000?
Your response must be concise. 1.02. What is the ratio of the Employment to population ratio(%) in Venezuela in 1993 to that in 2000?
Your answer should be very brief. 1.04. What is the ratio of the Employment to population ratio(%) of Middle East & North Africa (developing only) in 1994 to that in 1995?
Give a very brief answer. 1.01. What is the ratio of the Employment to population ratio(%) in Eritrea in 1994 to that in 1995?
Offer a very short reply. 1. What is the ratio of the Employment to population ratio(%) in Middle East & North Africa (developing only) in 1994 to that in 1996?
Your response must be concise. 1.02. What is the ratio of the Employment to population ratio(%) of Croatia in 1994 to that in 1996?
Your response must be concise. 1.03. What is the ratio of the Employment to population ratio(%) of Eritrea in 1994 to that in 1996?
Offer a terse response. 1. What is the ratio of the Employment to population ratio(%) of Middle East & North Africa (developing only) in 1994 to that in 1997?
Your response must be concise. 1.01. What is the ratio of the Employment to population ratio(%) of Croatia in 1994 to that in 1997?
Make the answer very short. 1.04. What is the ratio of the Employment to population ratio(%) in Eritrea in 1994 to that in 1997?
Give a very brief answer. 1.01. What is the ratio of the Employment to population ratio(%) of Venezuela in 1994 to that in 1997?
Your answer should be very brief. 0.98. What is the ratio of the Employment to population ratio(%) of Middle East & North Africa (developing only) in 1994 to that in 1998?
Your response must be concise. 1.02. What is the ratio of the Employment to population ratio(%) of Croatia in 1994 to that in 1998?
Provide a short and direct response. 1.06. What is the ratio of the Employment to population ratio(%) of Eritrea in 1994 to that in 1998?
Provide a succinct answer. 1.01. What is the ratio of the Employment to population ratio(%) in Venezuela in 1994 to that in 1998?
Keep it short and to the point. 0.99. What is the ratio of the Employment to population ratio(%) of Middle East & North Africa (developing only) in 1994 to that in 1999?
Make the answer very short. 1.01. What is the ratio of the Employment to population ratio(%) of Croatia in 1994 to that in 1999?
Your response must be concise. 1.1. What is the ratio of the Employment to population ratio(%) of Venezuela in 1994 to that in 1999?
Your answer should be compact. 1.03. What is the ratio of the Employment to population ratio(%) in Middle East & North Africa (developing only) in 1994 to that in 2000?
Keep it short and to the point. 1.03. What is the ratio of the Employment to population ratio(%) of Croatia in 1994 to that in 2000?
Offer a very short reply. 1.15. What is the ratio of the Employment to population ratio(%) in Eritrea in 1994 to that in 2000?
Keep it short and to the point. 1.02. What is the ratio of the Employment to population ratio(%) of Venezuela in 1994 to that in 2000?
Ensure brevity in your answer.  1.03. What is the ratio of the Employment to population ratio(%) of Croatia in 1995 to that in 1996?
Keep it short and to the point. 1.01. What is the ratio of the Employment to population ratio(%) in Middle East & North Africa (developing only) in 1995 to that in 1997?
Offer a very short reply. 1. What is the ratio of the Employment to population ratio(%) of Croatia in 1995 to that in 1997?
Offer a terse response. 1.02. What is the ratio of the Employment to population ratio(%) in Middle East & North Africa (developing only) in 1995 to that in 1998?
Offer a terse response. 1.01. What is the ratio of the Employment to population ratio(%) in Croatia in 1995 to that in 1998?
Ensure brevity in your answer.  1.05. What is the ratio of the Employment to population ratio(%) of Eritrea in 1995 to that in 1998?
Ensure brevity in your answer.  1.01. What is the ratio of the Employment to population ratio(%) of Venezuela in 1995 to that in 1998?
Keep it short and to the point. 0.99. What is the ratio of the Employment to population ratio(%) of Croatia in 1995 to that in 1999?
Make the answer very short. 1.09. What is the ratio of the Employment to population ratio(%) in Eritrea in 1995 to that in 1999?
Your response must be concise. 1.01. What is the ratio of the Employment to population ratio(%) of Venezuela in 1995 to that in 1999?
Give a very brief answer. 1.03. What is the ratio of the Employment to population ratio(%) in Middle East & North Africa (developing only) in 1995 to that in 2000?
Offer a very short reply. 1.02. What is the ratio of the Employment to population ratio(%) in Croatia in 1995 to that in 2000?
Your answer should be very brief. 1.13. What is the ratio of the Employment to population ratio(%) in Eritrea in 1995 to that in 2000?
Offer a terse response. 1.02. What is the ratio of the Employment to population ratio(%) in Venezuela in 1995 to that in 2000?
Offer a very short reply. 1.03. What is the ratio of the Employment to population ratio(%) in Middle East & North Africa (developing only) in 1996 to that in 1997?
Provide a succinct answer. 1. What is the ratio of the Employment to population ratio(%) in Croatia in 1996 to that in 1997?
Your answer should be very brief. 1.01. What is the ratio of the Employment to population ratio(%) in Eritrea in 1996 to that in 1997?
Give a very brief answer. 1. What is the ratio of the Employment to population ratio(%) in Venezuela in 1996 to that in 1997?
Make the answer very short. 0.98. What is the ratio of the Employment to population ratio(%) of Middle East & North Africa (developing only) in 1996 to that in 1998?
Offer a terse response. 1. What is the ratio of the Employment to population ratio(%) in Croatia in 1996 to that in 1998?
Keep it short and to the point. 1.03. What is the ratio of the Employment to population ratio(%) of Eritrea in 1996 to that in 1998?
Keep it short and to the point. 1.01. What is the ratio of the Employment to population ratio(%) in Venezuela in 1996 to that in 1998?
Make the answer very short. 0.99. What is the ratio of the Employment to population ratio(%) of Middle East & North Africa (developing only) in 1996 to that in 1999?
Make the answer very short. 0.99. What is the ratio of the Employment to population ratio(%) of Croatia in 1996 to that in 1999?
Keep it short and to the point. 1.07. What is the ratio of the Employment to population ratio(%) in Eritrea in 1996 to that in 1999?
Your response must be concise. 1.01. What is the ratio of the Employment to population ratio(%) of Venezuela in 1996 to that in 1999?
Ensure brevity in your answer.  1.02. What is the ratio of the Employment to population ratio(%) in Middle East & North Africa (developing only) in 1996 to that in 2000?
Provide a short and direct response. 1.01. What is the ratio of the Employment to population ratio(%) of Croatia in 1996 to that in 2000?
Offer a terse response. 1.12. What is the ratio of the Employment to population ratio(%) of Eritrea in 1996 to that in 2000?
Your answer should be very brief. 1.02. What is the ratio of the Employment to population ratio(%) in Venezuela in 1996 to that in 2000?
Ensure brevity in your answer.  1.03. What is the ratio of the Employment to population ratio(%) of Croatia in 1997 to that in 1998?
Provide a succinct answer. 1.03. What is the ratio of the Employment to population ratio(%) of Eritrea in 1997 to that in 1998?
Provide a short and direct response. 1. What is the ratio of the Employment to population ratio(%) of Venezuela in 1997 to that in 1998?
Your response must be concise. 1.01. What is the ratio of the Employment to population ratio(%) in Middle East & North Africa (developing only) in 1997 to that in 1999?
Offer a very short reply. 1. What is the ratio of the Employment to population ratio(%) of Croatia in 1997 to that in 1999?
Ensure brevity in your answer.  1.07. What is the ratio of the Employment to population ratio(%) in Eritrea in 1997 to that in 1999?
Offer a very short reply. 1.01. What is the ratio of the Employment to population ratio(%) in Venezuela in 1997 to that in 1999?
Your answer should be very brief. 1.04. What is the ratio of the Employment to population ratio(%) of Croatia in 1997 to that in 2000?
Make the answer very short. 1.11. What is the ratio of the Employment to population ratio(%) of Eritrea in 1997 to that in 2000?
Your response must be concise. 1.01. What is the ratio of the Employment to population ratio(%) in Venezuela in 1997 to that in 2000?
Keep it short and to the point. 1.05. What is the ratio of the Employment to population ratio(%) of Middle East & North Africa (developing only) in 1998 to that in 1999?
Keep it short and to the point. 0.99. What is the ratio of the Employment to population ratio(%) of Croatia in 1998 to that in 1999?
Offer a very short reply. 1.04. What is the ratio of the Employment to population ratio(%) of Venezuela in 1998 to that in 1999?
Make the answer very short. 1.04. What is the ratio of the Employment to population ratio(%) of Croatia in 1998 to that in 2000?
Offer a terse response. 1.08. What is the ratio of the Employment to population ratio(%) of Eritrea in 1998 to that in 2000?
Ensure brevity in your answer.  1.01. What is the ratio of the Employment to population ratio(%) in Venezuela in 1998 to that in 2000?
Ensure brevity in your answer.  1.04. What is the ratio of the Employment to population ratio(%) in Middle East & North Africa (developing only) in 1999 to that in 2000?
Ensure brevity in your answer.  1.02. What is the ratio of the Employment to population ratio(%) of Croatia in 1999 to that in 2000?
Your answer should be compact. 1.04. What is the ratio of the Employment to population ratio(%) in Eritrea in 1999 to that in 2000?
Provide a succinct answer. 1. What is the difference between the highest and the second highest Employment to population ratio(%) in Middle East & North Africa (developing only)?
Your answer should be compact. 0.23. What is the difference between the highest and the lowest Employment to population ratio(%) of Middle East & North Africa (developing only)?
Your answer should be very brief. 1.88. What is the difference between the highest and the lowest Employment to population ratio(%) of Croatia?
Offer a terse response. 8.7. What is the difference between the highest and the lowest Employment to population ratio(%) of Eritrea?
Give a very brief answer. 1.5. 